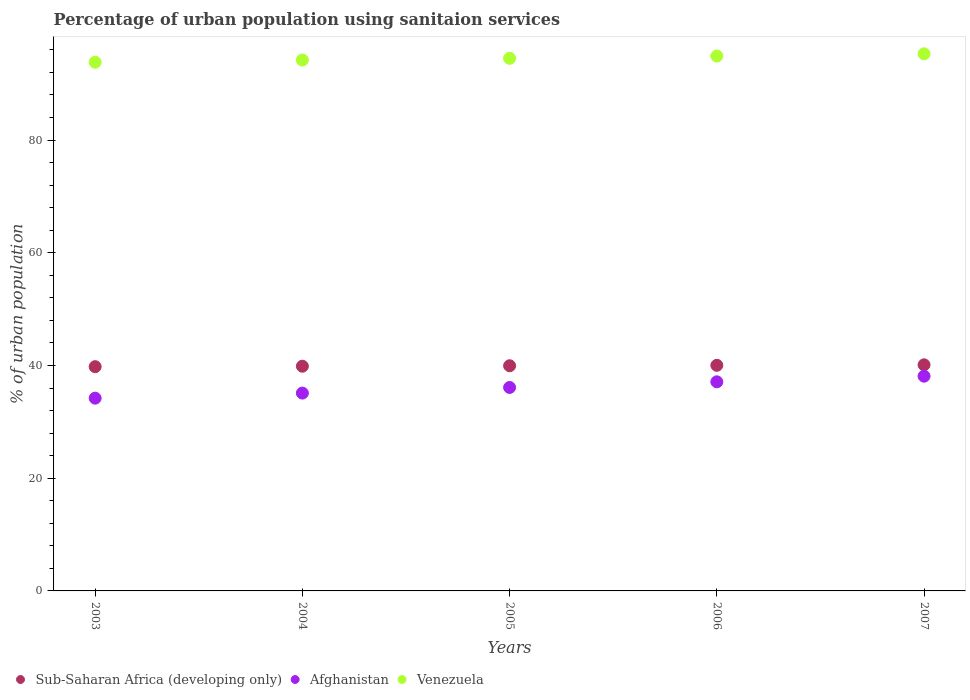How many different coloured dotlines are there?
Your answer should be very brief. 3. What is the percentage of urban population using sanitaion services in Sub-Saharan Africa (developing only) in 2005?
Make the answer very short. 39.95. Across all years, what is the maximum percentage of urban population using sanitaion services in Afghanistan?
Offer a terse response. 38.1. Across all years, what is the minimum percentage of urban population using sanitaion services in Sub-Saharan Africa (developing only)?
Make the answer very short. 39.79. What is the total percentage of urban population using sanitaion services in Sub-Saharan Africa (developing only) in the graph?
Give a very brief answer. 199.75. What is the difference between the percentage of urban population using sanitaion services in Afghanistan in 2006 and the percentage of urban population using sanitaion services in Sub-Saharan Africa (developing only) in 2003?
Make the answer very short. -2.69. What is the average percentage of urban population using sanitaion services in Sub-Saharan Africa (developing only) per year?
Keep it short and to the point. 39.95. In the year 2003, what is the difference between the percentage of urban population using sanitaion services in Sub-Saharan Africa (developing only) and percentage of urban population using sanitaion services in Afghanistan?
Ensure brevity in your answer.  5.59. In how many years, is the percentage of urban population using sanitaion services in Afghanistan greater than 12 %?
Provide a short and direct response. 5. What is the ratio of the percentage of urban population using sanitaion services in Afghanistan in 2005 to that in 2007?
Give a very brief answer. 0.95. Is the percentage of urban population using sanitaion services in Sub-Saharan Africa (developing only) in 2003 less than that in 2004?
Offer a terse response. Yes. Is the difference between the percentage of urban population using sanitaion services in Sub-Saharan Africa (developing only) in 2003 and 2007 greater than the difference between the percentage of urban population using sanitaion services in Afghanistan in 2003 and 2007?
Provide a short and direct response. Yes. What is the difference between the highest and the second highest percentage of urban population using sanitaion services in Sub-Saharan Africa (developing only)?
Keep it short and to the point. 0.09. What is the difference between the highest and the lowest percentage of urban population using sanitaion services in Venezuela?
Provide a short and direct response. 1.5. In how many years, is the percentage of urban population using sanitaion services in Sub-Saharan Africa (developing only) greater than the average percentage of urban population using sanitaion services in Sub-Saharan Africa (developing only) taken over all years?
Ensure brevity in your answer.  2. Is the sum of the percentage of urban population using sanitaion services in Sub-Saharan Africa (developing only) in 2005 and 2007 greater than the maximum percentage of urban population using sanitaion services in Venezuela across all years?
Provide a succinct answer. No. Is the percentage of urban population using sanitaion services in Afghanistan strictly less than the percentage of urban population using sanitaion services in Sub-Saharan Africa (developing only) over the years?
Your response must be concise. Yes. What is the difference between two consecutive major ticks on the Y-axis?
Make the answer very short. 20. Are the values on the major ticks of Y-axis written in scientific E-notation?
Offer a very short reply. No. Does the graph contain any zero values?
Your answer should be compact. No. How are the legend labels stacked?
Your response must be concise. Horizontal. What is the title of the graph?
Your answer should be compact. Percentage of urban population using sanitaion services. Does "Lao PDR" appear as one of the legend labels in the graph?
Your response must be concise. No. What is the label or title of the Y-axis?
Your answer should be very brief. % of urban population. What is the % of urban population in Sub-Saharan Africa (developing only) in 2003?
Make the answer very short. 39.79. What is the % of urban population of Afghanistan in 2003?
Give a very brief answer. 34.2. What is the % of urban population in Venezuela in 2003?
Keep it short and to the point. 93.8. What is the % of urban population of Sub-Saharan Africa (developing only) in 2004?
Offer a terse response. 39.87. What is the % of urban population in Afghanistan in 2004?
Make the answer very short. 35.1. What is the % of urban population of Venezuela in 2004?
Keep it short and to the point. 94.2. What is the % of urban population of Sub-Saharan Africa (developing only) in 2005?
Ensure brevity in your answer.  39.95. What is the % of urban population of Afghanistan in 2005?
Offer a terse response. 36.1. What is the % of urban population in Venezuela in 2005?
Make the answer very short. 94.5. What is the % of urban population in Sub-Saharan Africa (developing only) in 2006?
Your answer should be very brief. 40.03. What is the % of urban population of Afghanistan in 2006?
Give a very brief answer. 37.1. What is the % of urban population of Venezuela in 2006?
Keep it short and to the point. 94.9. What is the % of urban population of Sub-Saharan Africa (developing only) in 2007?
Keep it short and to the point. 40.12. What is the % of urban population of Afghanistan in 2007?
Offer a terse response. 38.1. What is the % of urban population of Venezuela in 2007?
Ensure brevity in your answer.  95.3. Across all years, what is the maximum % of urban population in Sub-Saharan Africa (developing only)?
Your answer should be compact. 40.12. Across all years, what is the maximum % of urban population in Afghanistan?
Your response must be concise. 38.1. Across all years, what is the maximum % of urban population of Venezuela?
Offer a terse response. 95.3. Across all years, what is the minimum % of urban population of Sub-Saharan Africa (developing only)?
Your answer should be very brief. 39.79. Across all years, what is the minimum % of urban population in Afghanistan?
Your answer should be very brief. 34.2. Across all years, what is the minimum % of urban population in Venezuela?
Offer a very short reply. 93.8. What is the total % of urban population of Sub-Saharan Africa (developing only) in the graph?
Make the answer very short. 199.75. What is the total % of urban population of Afghanistan in the graph?
Ensure brevity in your answer.  180.6. What is the total % of urban population in Venezuela in the graph?
Your response must be concise. 472.7. What is the difference between the % of urban population of Sub-Saharan Africa (developing only) in 2003 and that in 2004?
Ensure brevity in your answer.  -0.08. What is the difference between the % of urban population of Afghanistan in 2003 and that in 2004?
Offer a very short reply. -0.9. What is the difference between the % of urban population in Venezuela in 2003 and that in 2004?
Make the answer very short. -0.4. What is the difference between the % of urban population of Sub-Saharan Africa (developing only) in 2003 and that in 2005?
Your response must be concise. -0.16. What is the difference between the % of urban population of Afghanistan in 2003 and that in 2005?
Provide a short and direct response. -1.9. What is the difference between the % of urban population of Venezuela in 2003 and that in 2005?
Offer a terse response. -0.7. What is the difference between the % of urban population in Sub-Saharan Africa (developing only) in 2003 and that in 2006?
Offer a very short reply. -0.24. What is the difference between the % of urban population in Venezuela in 2003 and that in 2006?
Offer a terse response. -1.1. What is the difference between the % of urban population in Sub-Saharan Africa (developing only) in 2003 and that in 2007?
Give a very brief answer. -0.33. What is the difference between the % of urban population in Afghanistan in 2003 and that in 2007?
Give a very brief answer. -3.9. What is the difference between the % of urban population of Sub-Saharan Africa (developing only) in 2004 and that in 2005?
Give a very brief answer. -0.08. What is the difference between the % of urban population of Venezuela in 2004 and that in 2005?
Provide a short and direct response. -0.3. What is the difference between the % of urban population in Sub-Saharan Africa (developing only) in 2004 and that in 2006?
Provide a short and direct response. -0.16. What is the difference between the % of urban population of Afghanistan in 2004 and that in 2006?
Your answer should be compact. -2. What is the difference between the % of urban population of Venezuela in 2004 and that in 2006?
Keep it short and to the point. -0.7. What is the difference between the % of urban population in Sub-Saharan Africa (developing only) in 2004 and that in 2007?
Offer a very short reply. -0.25. What is the difference between the % of urban population of Afghanistan in 2004 and that in 2007?
Offer a very short reply. -3. What is the difference between the % of urban population in Venezuela in 2004 and that in 2007?
Provide a succinct answer. -1.1. What is the difference between the % of urban population of Sub-Saharan Africa (developing only) in 2005 and that in 2006?
Offer a very short reply. -0.08. What is the difference between the % of urban population of Afghanistan in 2005 and that in 2006?
Offer a terse response. -1. What is the difference between the % of urban population of Venezuela in 2005 and that in 2006?
Provide a short and direct response. -0.4. What is the difference between the % of urban population in Sub-Saharan Africa (developing only) in 2005 and that in 2007?
Your response must be concise. -0.17. What is the difference between the % of urban population of Afghanistan in 2005 and that in 2007?
Give a very brief answer. -2. What is the difference between the % of urban population in Sub-Saharan Africa (developing only) in 2006 and that in 2007?
Your response must be concise. -0.09. What is the difference between the % of urban population in Afghanistan in 2006 and that in 2007?
Offer a terse response. -1. What is the difference between the % of urban population in Sub-Saharan Africa (developing only) in 2003 and the % of urban population in Afghanistan in 2004?
Your answer should be compact. 4.69. What is the difference between the % of urban population in Sub-Saharan Africa (developing only) in 2003 and the % of urban population in Venezuela in 2004?
Provide a short and direct response. -54.41. What is the difference between the % of urban population in Afghanistan in 2003 and the % of urban population in Venezuela in 2004?
Offer a terse response. -60. What is the difference between the % of urban population in Sub-Saharan Africa (developing only) in 2003 and the % of urban population in Afghanistan in 2005?
Ensure brevity in your answer.  3.69. What is the difference between the % of urban population of Sub-Saharan Africa (developing only) in 2003 and the % of urban population of Venezuela in 2005?
Your response must be concise. -54.71. What is the difference between the % of urban population of Afghanistan in 2003 and the % of urban population of Venezuela in 2005?
Offer a terse response. -60.3. What is the difference between the % of urban population of Sub-Saharan Africa (developing only) in 2003 and the % of urban population of Afghanistan in 2006?
Keep it short and to the point. 2.69. What is the difference between the % of urban population in Sub-Saharan Africa (developing only) in 2003 and the % of urban population in Venezuela in 2006?
Ensure brevity in your answer.  -55.11. What is the difference between the % of urban population of Afghanistan in 2003 and the % of urban population of Venezuela in 2006?
Your response must be concise. -60.7. What is the difference between the % of urban population in Sub-Saharan Africa (developing only) in 2003 and the % of urban population in Afghanistan in 2007?
Make the answer very short. 1.69. What is the difference between the % of urban population of Sub-Saharan Africa (developing only) in 2003 and the % of urban population of Venezuela in 2007?
Ensure brevity in your answer.  -55.51. What is the difference between the % of urban population of Afghanistan in 2003 and the % of urban population of Venezuela in 2007?
Your response must be concise. -61.1. What is the difference between the % of urban population of Sub-Saharan Africa (developing only) in 2004 and the % of urban population of Afghanistan in 2005?
Offer a very short reply. 3.77. What is the difference between the % of urban population in Sub-Saharan Africa (developing only) in 2004 and the % of urban population in Venezuela in 2005?
Offer a terse response. -54.63. What is the difference between the % of urban population in Afghanistan in 2004 and the % of urban population in Venezuela in 2005?
Keep it short and to the point. -59.4. What is the difference between the % of urban population in Sub-Saharan Africa (developing only) in 2004 and the % of urban population in Afghanistan in 2006?
Provide a succinct answer. 2.77. What is the difference between the % of urban population of Sub-Saharan Africa (developing only) in 2004 and the % of urban population of Venezuela in 2006?
Your answer should be compact. -55.03. What is the difference between the % of urban population in Afghanistan in 2004 and the % of urban population in Venezuela in 2006?
Offer a very short reply. -59.8. What is the difference between the % of urban population of Sub-Saharan Africa (developing only) in 2004 and the % of urban population of Afghanistan in 2007?
Your answer should be very brief. 1.77. What is the difference between the % of urban population of Sub-Saharan Africa (developing only) in 2004 and the % of urban population of Venezuela in 2007?
Make the answer very short. -55.43. What is the difference between the % of urban population of Afghanistan in 2004 and the % of urban population of Venezuela in 2007?
Provide a succinct answer. -60.2. What is the difference between the % of urban population in Sub-Saharan Africa (developing only) in 2005 and the % of urban population in Afghanistan in 2006?
Make the answer very short. 2.85. What is the difference between the % of urban population of Sub-Saharan Africa (developing only) in 2005 and the % of urban population of Venezuela in 2006?
Offer a very short reply. -54.95. What is the difference between the % of urban population of Afghanistan in 2005 and the % of urban population of Venezuela in 2006?
Ensure brevity in your answer.  -58.8. What is the difference between the % of urban population in Sub-Saharan Africa (developing only) in 2005 and the % of urban population in Afghanistan in 2007?
Your answer should be very brief. 1.85. What is the difference between the % of urban population in Sub-Saharan Africa (developing only) in 2005 and the % of urban population in Venezuela in 2007?
Your answer should be compact. -55.35. What is the difference between the % of urban population in Afghanistan in 2005 and the % of urban population in Venezuela in 2007?
Give a very brief answer. -59.2. What is the difference between the % of urban population of Sub-Saharan Africa (developing only) in 2006 and the % of urban population of Afghanistan in 2007?
Provide a short and direct response. 1.93. What is the difference between the % of urban population in Sub-Saharan Africa (developing only) in 2006 and the % of urban population in Venezuela in 2007?
Provide a succinct answer. -55.27. What is the difference between the % of urban population in Afghanistan in 2006 and the % of urban population in Venezuela in 2007?
Offer a terse response. -58.2. What is the average % of urban population in Sub-Saharan Africa (developing only) per year?
Your answer should be very brief. 39.95. What is the average % of urban population in Afghanistan per year?
Offer a terse response. 36.12. What is the average % of urban population in Venezuela per year?
Your answer should be very brief. 94.54. In the year 2003, what is the difference between the % of urban population of Sub-Saharan Africa (developing only) and % of urban population of Afghanistan?
Your response must be concise. 5.59. In the year 2003, what is the difference between the % of urban population in Sub-Saharan Africa (developing only) and % of urban population in Venezuela?
Provide a succinct answer. -54.01. In the year 2003, what is the difference between the % of urban population in Afghanistan and % of urban population in Venezuela?
Offer a terse response. -59.6. In the year 2004, what is the difference between the % of urban population of Sub-Saharan Africa (developing only) and % of urban population of Afghanistan?
Your answer should be compact. 4.77. In the year 2004, what is the difference between the % of urban population of Sub-Saharan Africa (developing only) and % of urban population of Venezuela?
Give a very brief answer. -54.33. In the year 2004, what is the difference between the % of urban population in Afghanistan and % of urban population in Venezuela?
Make the answer very short. -59.1. In the year 2005, what is the difference between the % of urban population in Sub-Saharan Africa (developing only) and % of urban population in Afghanistan?
Your response must be concise. 3.85. In the year 2005, what is the difference between the % of urban population in Sub-Saharan Africa (developing only) and % of urban population in Venezuela?
Make the answer very short. -54.55. In the year 2005, what is the difference between the % of urban population of Afghanistan and % of urban population of Venezuela?
Your response must be concise. -58.4. In the year 2006, what is the difference between the % of urban population in Sub-Saharan Africa (developing only) and % of urban population in Afghanistan?
Offer a terse response. 2.93. In the year 2006, what is the difference between the % of urban population of Sub-Saharan Africa (developing only) and % of urban population of Venezuela?
Provide a succinct answer. -54.87. In the year 2006, what is the difference between the % of urban population of Afghanistan and % of urban population of Venezuela?
Your answer should be compact. -57.8. In the year 2007, what is the difference between the % of urban population of Sub-Saharan Africa (developing only) and % of urban population of Afghanistan?
Keep it short and to the point. 2.02. In the year 2007, what is the difference between the % of urban population of Sub-Saharan Africa (developing only) and % of urban population of Venezuela?
Give a very brief answer. -55.18. In the year 2007, what is the difference between the % of urban population in Afghanistan and % of urban population in Venezuela?
Your answer should be compact. -57.2. What is the ratio of the % of urban population of Sub-Saharan Africa (developing only) in 2003 to that in 2004?
Your answer should be compact. 1. What is the ratio of the % of urban population in Afghanistan in 2003 to that in 2004?
Your answer should be very brief. 0.97. What is the ratio of the % of urban population in Sub-Saharan Africa (developing only) in 2003 to that in 2005?
Provide a succinct answer. 1. What is the ratio of the % of urban population of Afghanistan in 2003 to that in 2005?
Keep it short and to the point. 0.95. What is the ratio of the % of urban population in Sub-Saharan Africa (developing only) in 2003 to that in 2006?
Offer a very short reply. 0.99. What is the ratio of the % of urban population in Afghanistan in 2003 to that in 2006?
Give a very brief answer. 0.92. What is the ratio of the % of urban population in Venezuela in 2003 to that in 2006?
Provide a short and direct response. 0.99. What is the ratio of the % of urban population in Afghanistan in 2003 to that in 2007?
Offer a terse response. 0.9. What is the ratio of the % of urban population in Venezuela in 2003 to that in 2007?
Provide a succinct answer. 0.98. What is the ratio of the % of urban population of Afghanistan in 2004 to that in 2005?
Give a very brief answer. 0.97. What is the ratio of the % of urban population of Venezuela in 2004 to that in 2005?
Keep it short and to the point. 1. What is the ratio of the % of urban population in Sub-Saharan Africa (developing only) in 2004 to that in 2006?
Your response must be concise. 1. What is the ratio of the % of urban population in Afghanistan in 2004 to that in 2006?
Give a very brief answer. 0.95. What is the ratio of the % of urban population of Afghanistan in 2004 to that in 2007?
Make the answer very short. 0.92. What is the ratio of the % of urban population in Venezuela in 2004 to that in 2007?
Make the answer very short. 0.99. What is the ratio of the % of urban population of Venezuela in 2005 to that in 2006?
Offer a very short reply. 1. What is the ratio of the % of urban population in Sub-Saharan Africa (developing only) in 2005 to that in 2007?
Your answer should be compact. 1. What is the ratio of the % of urban population of Afghanistan in 2005 to that in 2007?
Offer a terse response. 0.95. What is the ratio of the % of urban population in Sub-Saharan Africa (developing only) in 2006 to that in 2007?
Keep it short and to the point. 1. What is the ratio of the % of urban population of Afghanistan in 2006 to that in 2007?
Give a very brief answer. 0.97. What is the difference between the highest and the second highest % of urban population of Sub-Saharan Africa (developing only)?
Offer a very short reply. 0.09. What is the difference between the highest and the second highest % of urban population in Afghanistan?
Make the answer very short. 1. What is the difference between the highest and the second highest % of urban population in Venezuela?
Keep it short and to the point. 0.4. What is the difference between the highest and the lowest % of urban population in Sub-Saharan Africa (developing only)?
Provide a succinct answer. 0.33. What is the difference between the highest and the lowest % of urban population in Afghanistan?
Keep it short and to the point. 3.9. What is the difference between the highest and the lowest % of urban population of Venezuela?
Give a very brief answer. 1.5. 